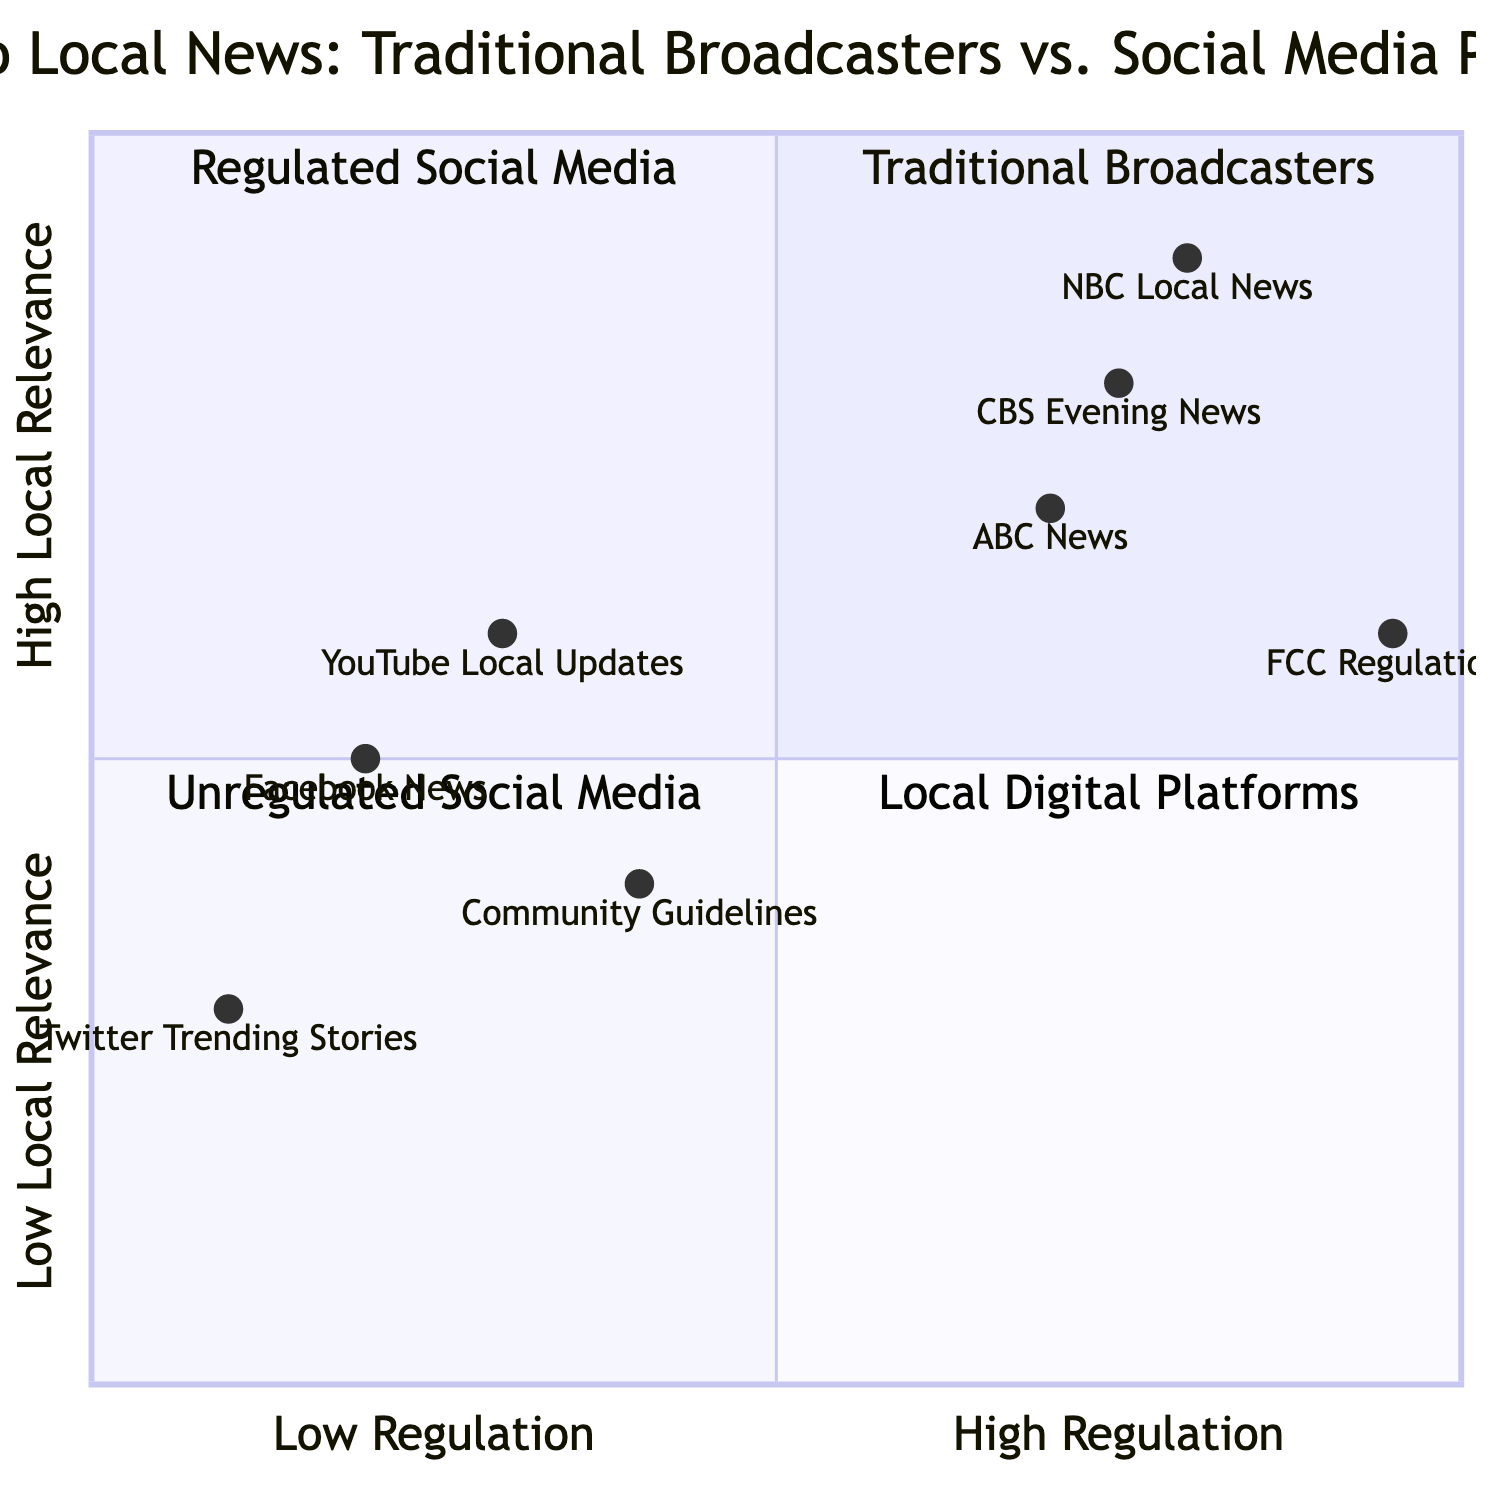What is the local relevance score of NBC Local News? NBC Local News has a local relevance score of 0.8, which can be found directly from its position in the chart.
Answer: 0.8 Which platform has the highest content regulation? FCC Regulations has the highest content regulation score at 0.95, as it appears to the far right on the regulation scale.
Answer: 0.95 How many elements are in the Unregulated Social Media quadrant? In the Unregulated Social Media quadrant, there are two elements: Facebook News and Twitter Trending Stories.
Answer: 2 What is the depth of coverage score for CBS Evening News? CBS Evening News has a depth of coverage score of 0.75, which is indicated on the vertical axis of the chart.
Answer: 0.75 Is YouTube Local Updates more locally relevant than Community Guidelines? Yes, YouTube Local Updates has a local relevance score of 0.6, while Community Guidelines has a score of 0.4, indicating greater local relevance for YouTube.
Answer: Yes Which element has the lowest local relevance score? Twitter Trending Stories has the lowest local relevance score at 0.3, as shown near the bottom of the vertical axis.
Answer: 0.3 Compare the trustworthiness of ABC News with Facebook News. ABC News has a trustworthiness score of 0.7, while Facebook News has a score of 0.2, indicating that ABC News is more trustworthy.
Answer: ABC News What quadrant does NBC Local News fall into? NBC Local News falls into the Traditional Broadcasters quadrant, represented in the top left area of the quadrant chart.
Answer: Traditional Broadcasters 